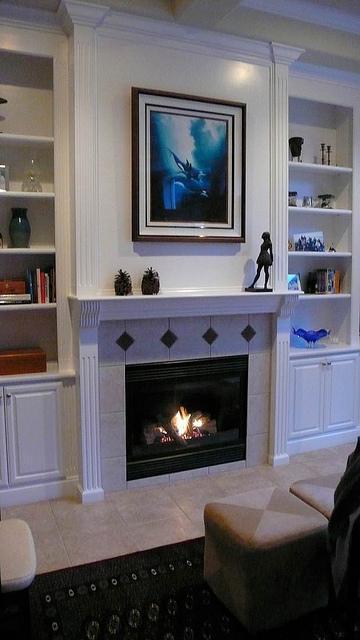How many women are in the picture?
Give a very brief answer. 0. How many license plates are on the shelves?
Give a very brief answer. 0. How many pictures are on the wall?
Give a very brief answer. 1. How many chairs are there?
Give a very brief answer. 2. How many blue cars are there?
Give a very brief answer. 0. 